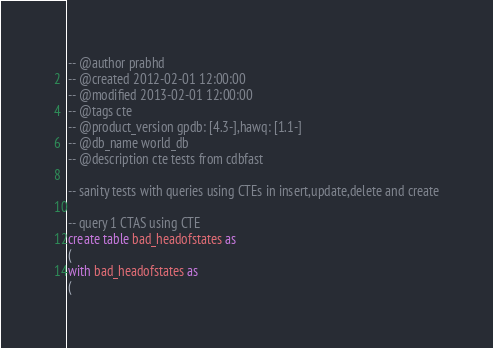Convert code to text. <code><loc_0><loc_0><loc_500><loc_500><_SQL_>-- @author prabhd 
-- @created 2012-02-01 12:00:00 
-- @modified 2013-02-01 12:00:00 
-- @tags cte
-- @product_version gpdb: [4.3-],hawq: [1.1-]
-- @db_name world_db
-- @description cte tests from cdbfast 

-- sanity tests with queries using CTEs in insert,update,delete and create

-- query 1 CTAS using CTE
create table bad_headofstates as 
(
with bad_headofstates as 
(</code> 